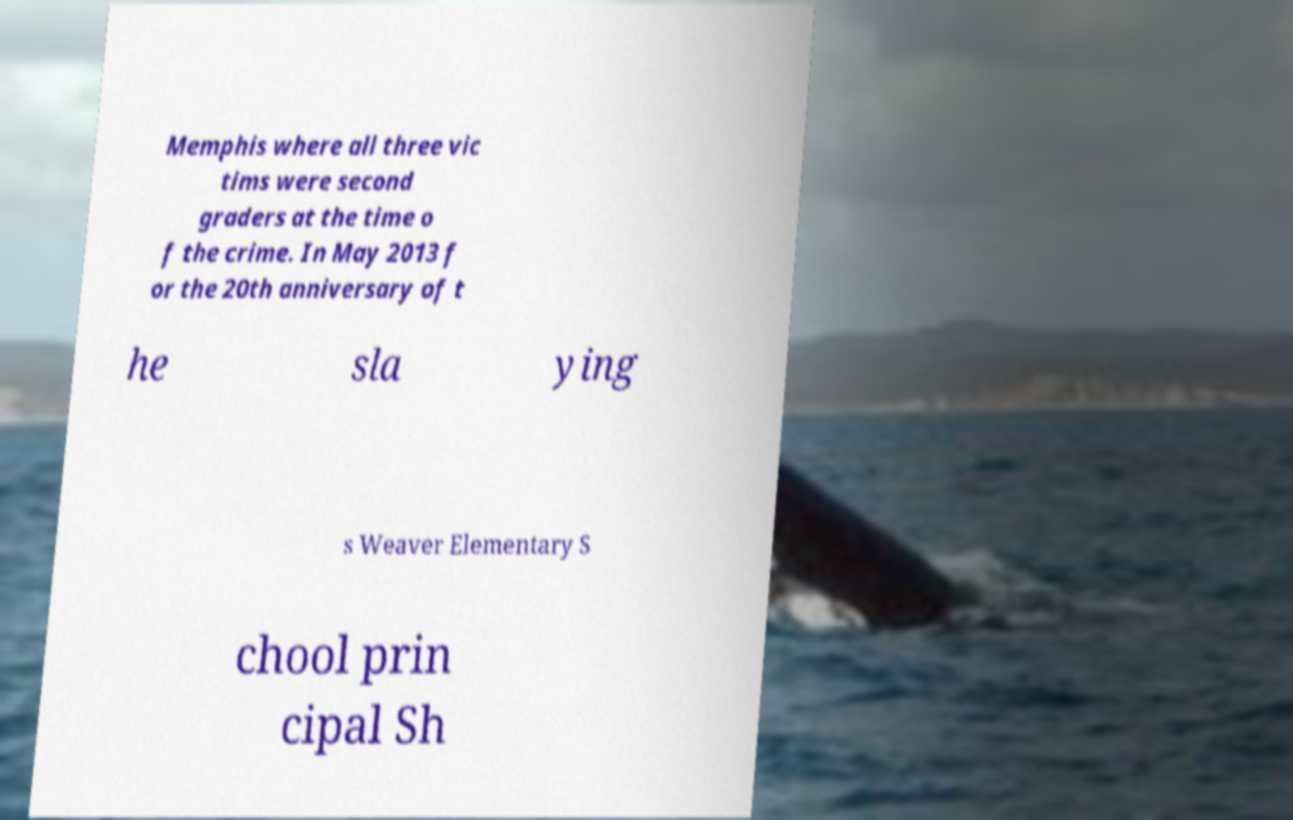Please identify and transcribe the text found in this image. Memphis where all three vic tims were second graders at the time o f the crime. In May 2013 f or the 20th anniversary of t he sla ying s Weaver Elementary S chool prin cipal Sh 